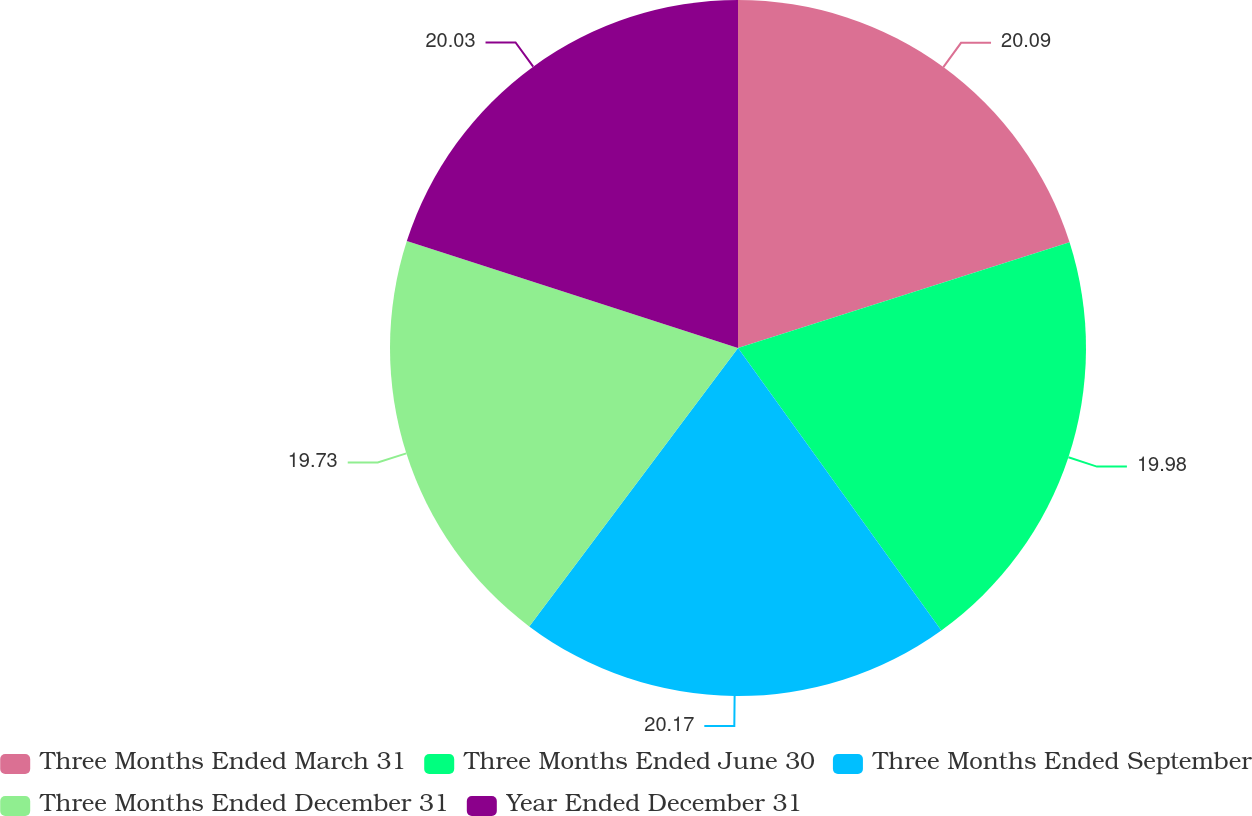<chart> <loc_0><loc_0><loc_500><loc_500><pie_chart><fcel>Three Months Ended March 31<fcel>Three Months Ended June 30<fcel>Three Months Ended September<fcel>Three Months Ended December 31<fcel>Year Ended December 31<nl><fcel>20.09%<fcel>19.98%<fcel>20.17%<fcel>19.73%<fcel>20.03%<nl></chart> 